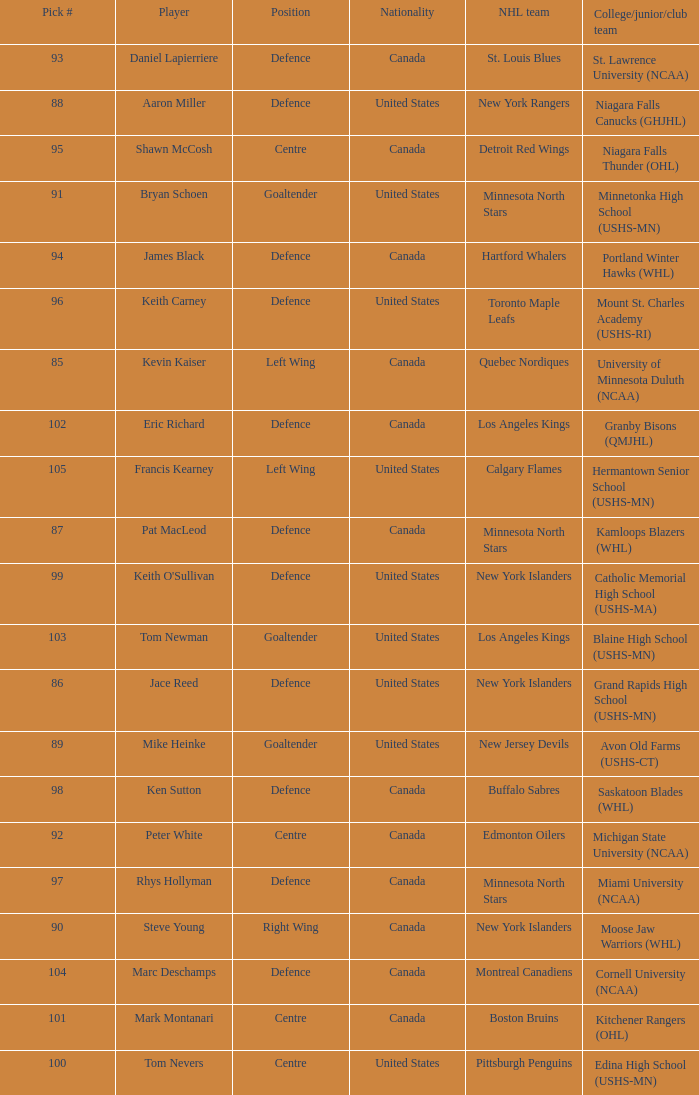What position did the #94 pick play? Defence. 